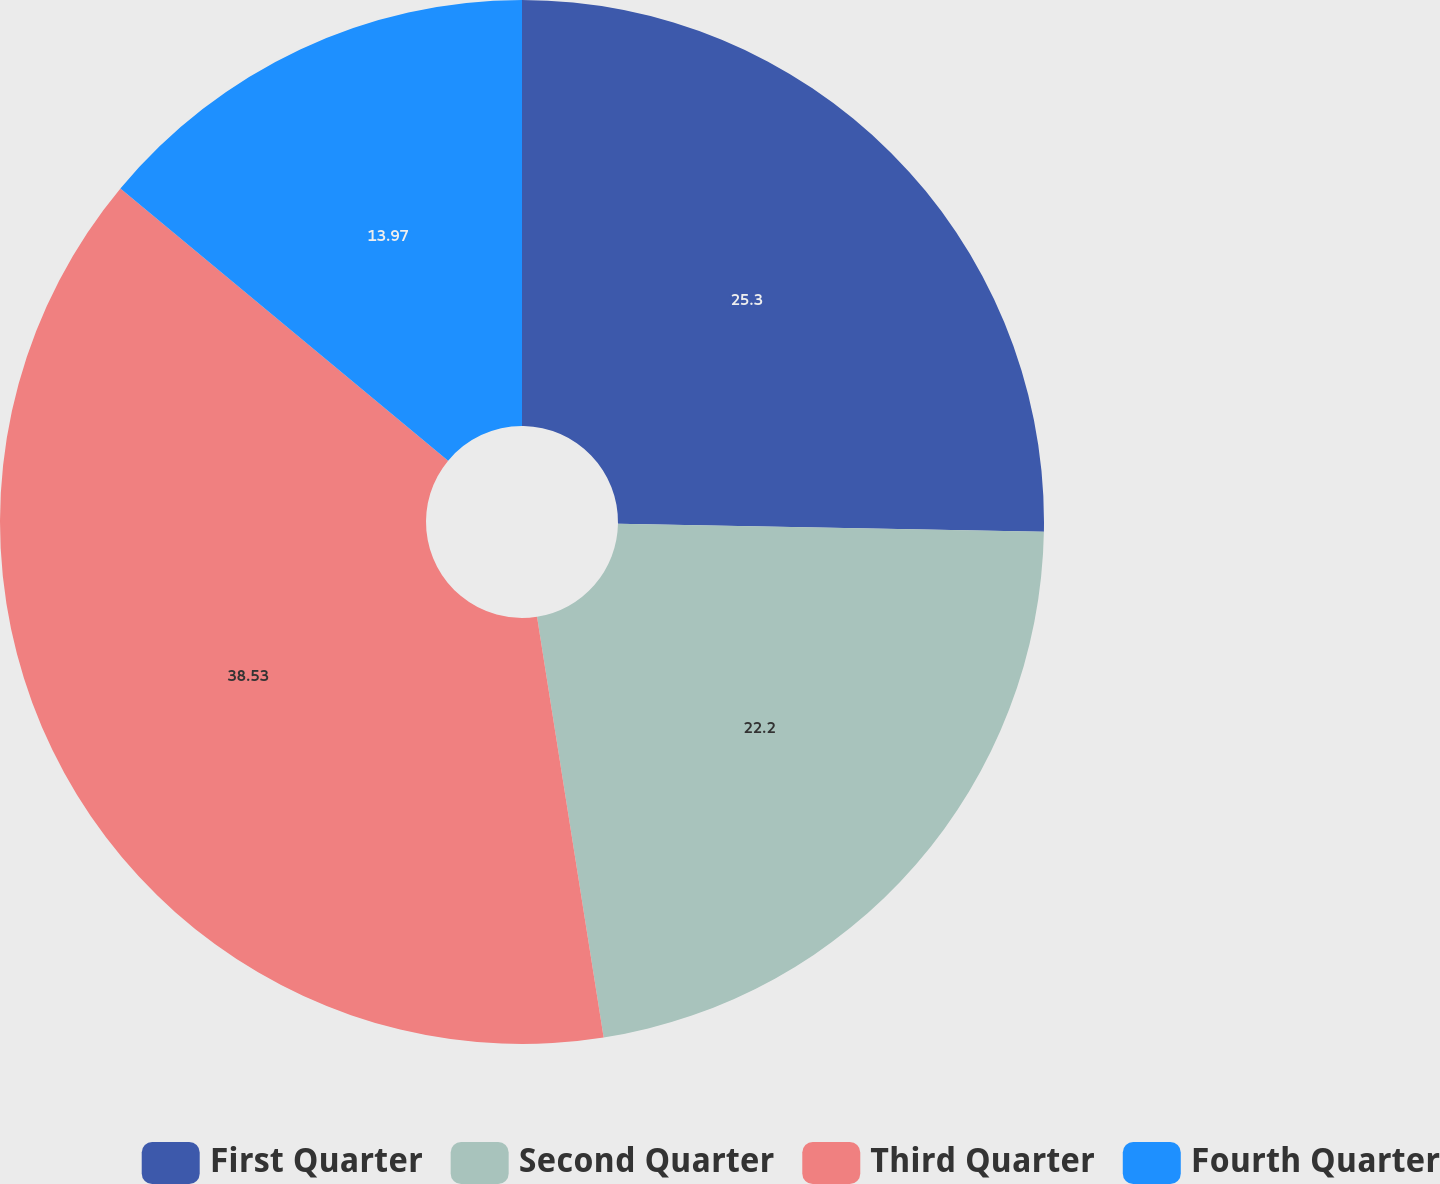<chart> <loc_0><loc_0><loc_500><loc_500><pie_chart><fcel>First Quarter<fcel>Second Quarter<fcel>Third Quarter<fcel>Fourth Quarter<nl><fcel>25.3%<fcel>22.2%<fcel>38.53%<fcel>13.97%<nl></chart> 